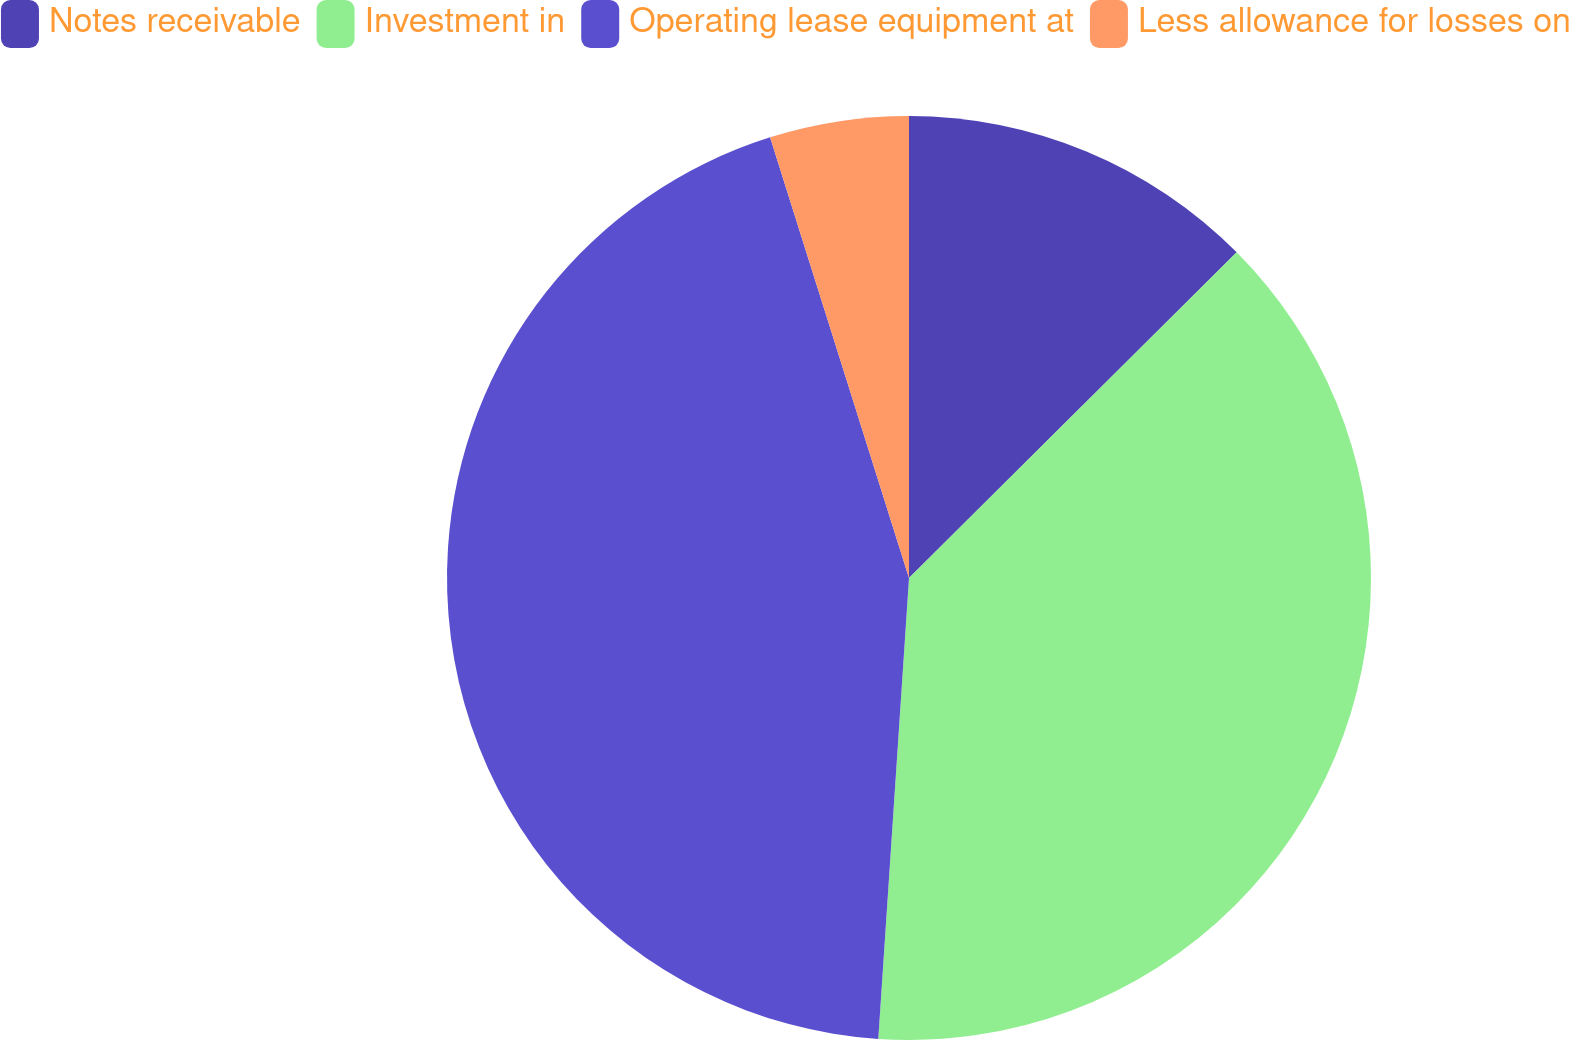Convert chart. <chart><loc_0><loc_0><loc_500><loc_500><pie_chart><fcel>Notes receivable<fcel>Investment in<fcel>Operating lease equipment at<fcel>Less allowance for losses on<nl><fcel>12.55%<fcel>38.51%<fcel>44.08%<fcel>4.86%<nl></chart> 